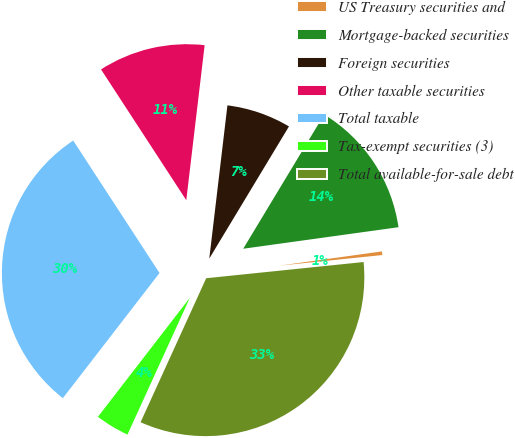<chart> <loc_0><loc_0><loc_500><loc_500><pie_chart><fcel>US Treasury securities and<fcel>Mortgage-backed securities<fcel>Foreign securities<fcel>Other taxable securities<fcel>Total taxable<fcel>Tax-exempt securities (3)<fcel>Total available-for-sale debt<nl><fcel>0.56%<fcel>14.17%<fcel>6.76%<fcel>11.07%<fcel>30.34%<fcel>3.66%<fcel>33.44%<nl></chart> 